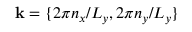Convert formula to latex. <formula><loc_0><loc_0><loc_500><loc_500>k = \{ 2 \pi n _ { x } / L _ { y } , { 2 } \pi n _ { y } / L _ { y } \}</formula> 